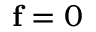Convert formula to latex. <formula><loc_0><loc_0><loc_500><loc_500>f = 0</formula> 